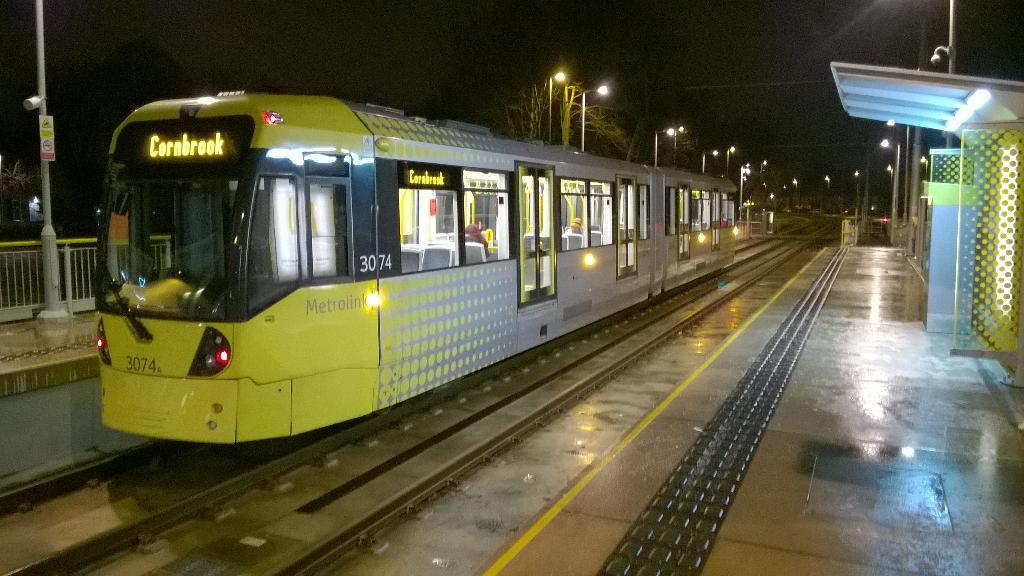<image>
Render a clear and concise summary of the photo. A yellow train has the destination of Cornbrook. 